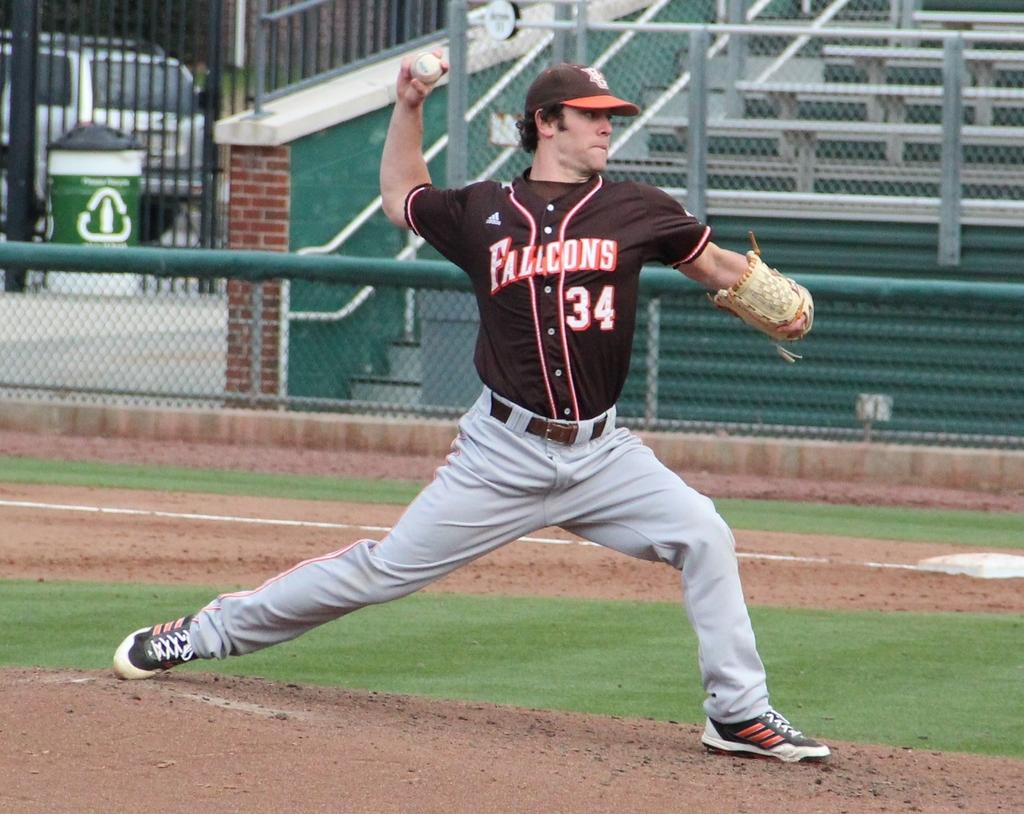<image>
Create a compact narrative representing the image presented. the number 34 is on a baseball jersey 